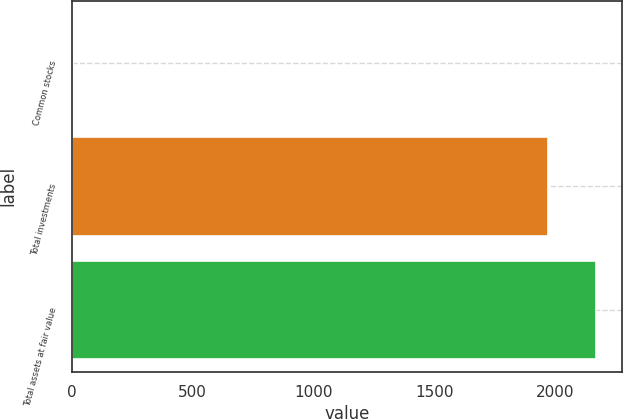Convert chart. <chart><loc_0><loc_0><loc_500><loc_500><bar_chart><fcel>Common stocks<fcel>Total investments<fcel>Total assets at fair value<nl><fcel>6<fcel>1969<fcel>2166.4<nl></chart> 